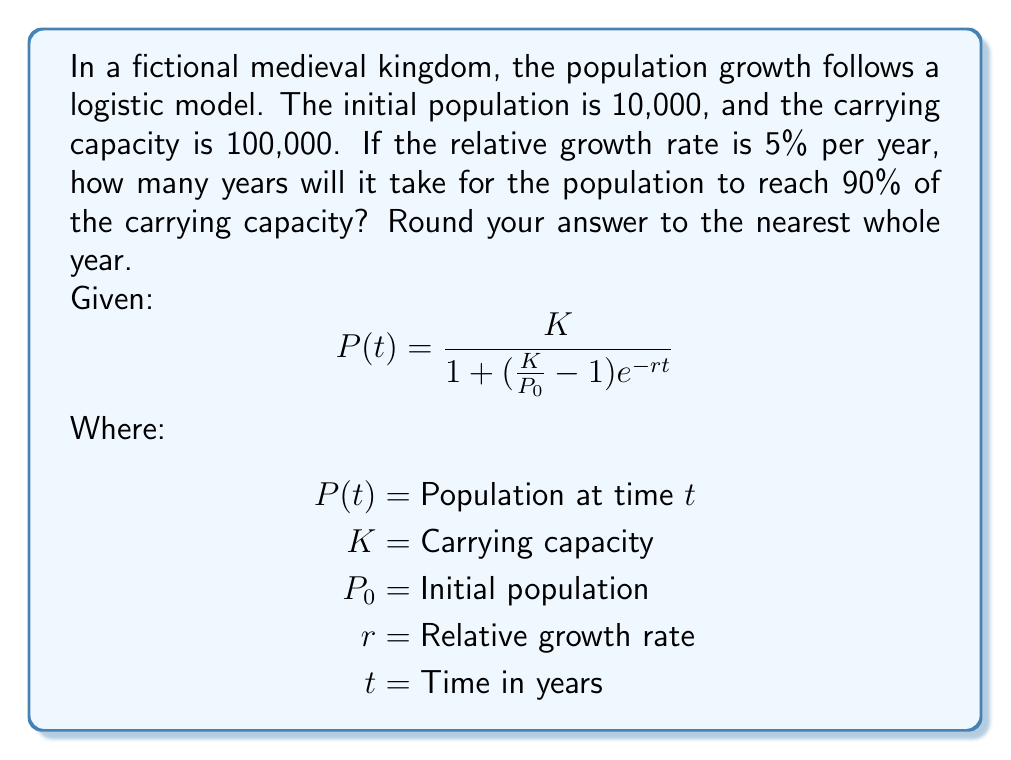Give your solution to this math problem. To solve this problem, we'll follow these steps:

1) We're looking for the time $t$ when the population reaches 90% of the carrying capacity. So, we need to solve:

   $P(t) = 0.9K = 90,000$

2) Substituting the given values into the logistic growth equation:

   $90,000 = \frac{100,000}{1 + (\frac{100,000}{10,000} - 1)e^{-0.05t}}$

3) Simplify:

   $0.9 = \frac{1}{1 + 9e^{-0.05t}}$

4) Multiply both sides by the denominator:

   $0.9(1 + 9e^{-0.05t}) = 1$

5) Expand:

   $0.9 + 8.1e^{-0.05t} = 1$

6) Subtract 0.9 from both sides:

   $8.1e^{-0.05t} = 0.1$

7) Divide both sides by 8.1:

   $e^{-0.05t} = \frac{0.1}{8.1} \approx 0.012345679$

8) Take the natural log of both sides:

   $-0.05t = \ln(0.012345679)$

9) Divide both sides by -0.05:

   $t = \frac{\ln(0.012345679)}{-0.05} \approx 88.72$

10) Rounding to the nearest whole year:

    $t \approx 89$ years
Answer: 89 years 